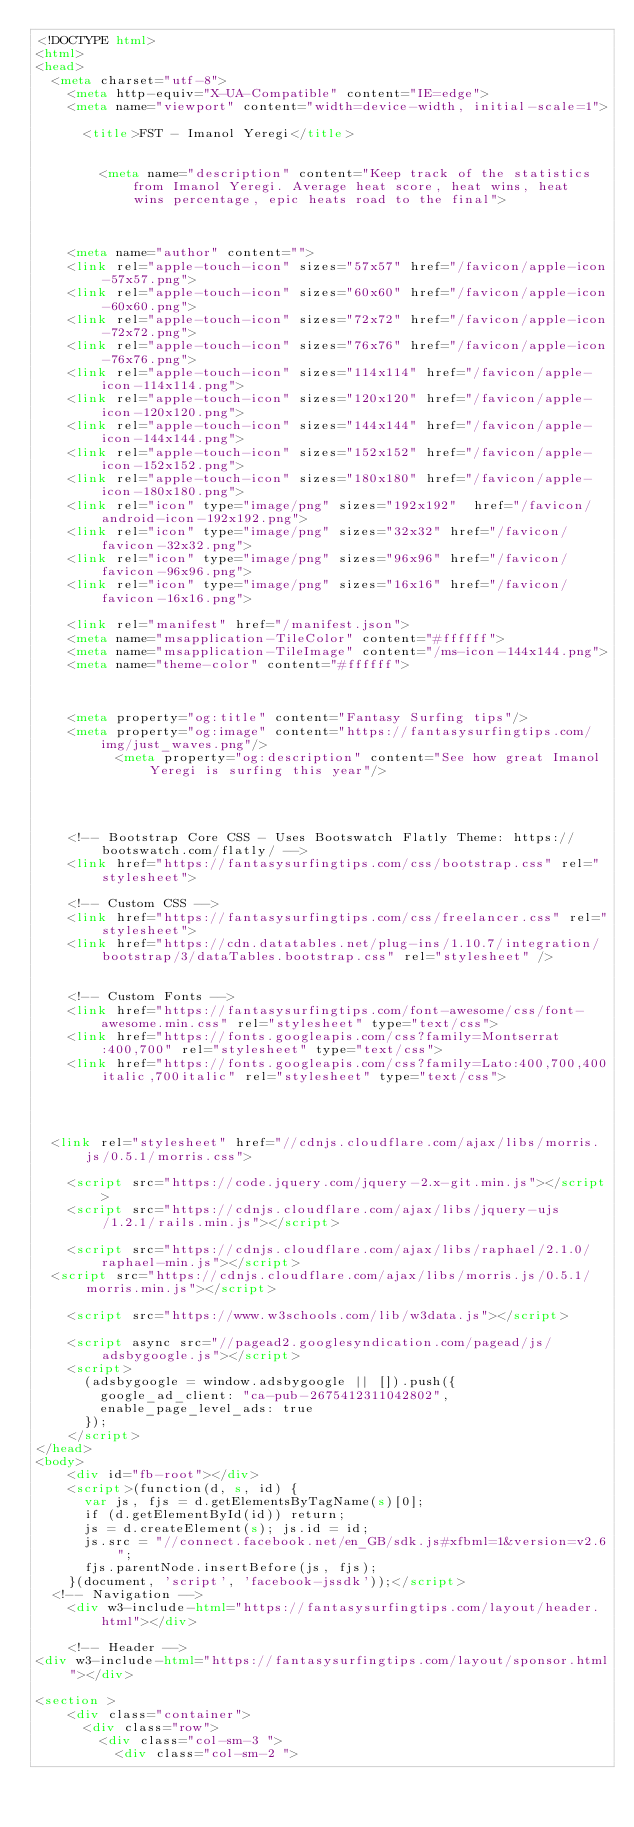<code> <loc_0><loc_0><loc_500><loc_500><_HTML_><!DOCTYPE html>
<html>
<head>
	<meta charset="utf-8">
    <meta http-equiv="X-UA-Compatible" content="IE=edge">
    <meta name="viewport" content="width=device-width, initial-scale=1">

    	<title>FST - Imanol Yeregi</title>

    
        <meta name="description" content="Keep track of the statistics from Imanol Yeregi. Average heat score, heat wins, heat wins percentage, epic heats road to the final">

    

    <meta name="author" content="">
    <link rel="apple-touch-icon" sizes="57x57" href="/favicon/apple-icon-57x57.png">
    <link rel="apple-touch-icon" sizes="60x60" href="/favicon/apple-icon-60x60.png">
    <link rel="apple-touch-icon" sizes="72x72" href="/favicon/apple-icon-72x72.png">
    <link rel="apple-touch-icon" sizes="76x76" href="/favicon/apple-icon-76x76.png">
    <link rel="apple-touch-icon" sizes="114x114" href="/favicon/apple-icon-114x114.png">
    <link rel="apple-touch-icon" sizes="120x120" href="/favicon/apple-icon-120x120.png">
    <link rel="apple-touch-icon" sizes="144x144" href="/favicon/apple-icon-144x144.png">
    <link rel="apple-touch-icon" sizes="152x152" href="/favicon/apple-icon-152x152.png">
    <link rel="apple-touch-icon" sizes="180x180" href="/favicon/apple-icon-180x180.png">
    <link rel="icon" type="image/png" sizes="192x192"  href="/favicon/android-icon-192x192.png">
    <link rel="icon" type="image/png" sizes="32x32" href="/favicon/favicon-32x32.png">
    <link rel="icon" type="image/png" sizes="96x96" href="/favicon/favicon-96x96.png">
    <link rel="icon" type="image/png" sizes="16x16" href="/favicon/favicon-16x16.png">

    <link rel="manifest" href="/manifest.json">
    <meta name="msapplication-TileColor" content="#ffffff">
    <meta name="msapplication-TileImage" content="/ms-icon-144x144.png">
    <meta name="theme-color" content="#ffffff">
    
    

    <meta property="og:title" content="Fantasy Surfing tips"/>
    <meta property="og:image" content="https://fantasysurfingtips.com/img/just_waves.png"/>
    	    <meta property="og:description" content="See how great Imanol Yeregi is surfing this year"/>


    

    <!-- Bootstrap Core CSS - Uses Bootswatch Flatly Theme: https://bootswatch.com/flatly/ -->
    <link href="https://fantasysurfingtips.com/css/bootstrap.css" rel="stylesheet">

    <!-- Custom CSS -->
    <link href="https://fantasysurfingtips.com/css/freelancer.css" rel="stylesheet">
    <link href="https://cdn.datatables.net/plug-ins/1.10.7/integration/bootstrap/3/dataTables.bootstrap.css" rel="stylesheet" />


    <!-- Custom Fonts -->
    <link href="https://fantasysurfingtips.com/font-awesome/css/font-awesome.min.css" rel="stylesheet" type="text/css">
    <link href="https://fonts.googleapis.com/css?family=Montserrat:400,700" rel="stylesheet" type="text/css">
    <link href="https://fonts.googleapis.com/css?family=Lato:400,700,400italic,700italic" rel="stylesheet" type="text/css">


  
 
 	<link rel="stylesheet" href="//cdnjs.cloudflare.com/ajax/libs/morris.js/0.5.1/morris.css">
	
    <script src="https://code.jquery.com/jquery-2.x-git.min.js"></script>
    <script src="https://cdnjs.cloudflare.com/ajax/libs/jquery-ujs/1.2.1/rails.min.js"></script>
    
    <script src="https://cdnjs.cloudflare.com/ajax/libs/raphael/2.1.0/raphael-min.js"></script>
	<script src="https://cdnjs.cloudflare.com/ajax/libs/morris.js/0.5.1/morris.min.js"></script>

    <script src="https://www.w3schools.com/lib/w3data.js"></script>

    <script async src="//pagead2.googlesyndication.com/pagead/js/adsbygoogle.js"></script>
    <script>
      (adsbygoogle = window.adsbygoogle || []).push({
        google_ad_client: "ca-pub-2675412311042802",
        enable_page_level_ads: true
      });
    </script>
</head>
<body>
    <div id="fb-root"></div>
    <script>(function(d, s, id) {
      var js, fjs = d.getElementsByTagName(s)[0];
      if (d.getElementById(id)) return;
      js = d.createElement(s); js.id = id;
      js.src = "//connect.facebook.net/en_GB/sdk.js#xfbml=1&version=v2.6";
      fjs.parentNode.insertBefore(js, fjs);
    }(document, 'script', 'facebook-jssdk'));</script>
	<!-- Navigation -->
    <div w3-include-html="https://fantasysurfingtips.com/layout/header.html"></div>
    
    <!-- Header -->
<div w3-include-html="https://fantasysurfingtips.com/layout/sponsor.html"></div> 

<section >
    <div class="container">
    	<div class="row">
    		<div class="col-sm-3 ">
    			<div class="col-sm-2 "></code> 